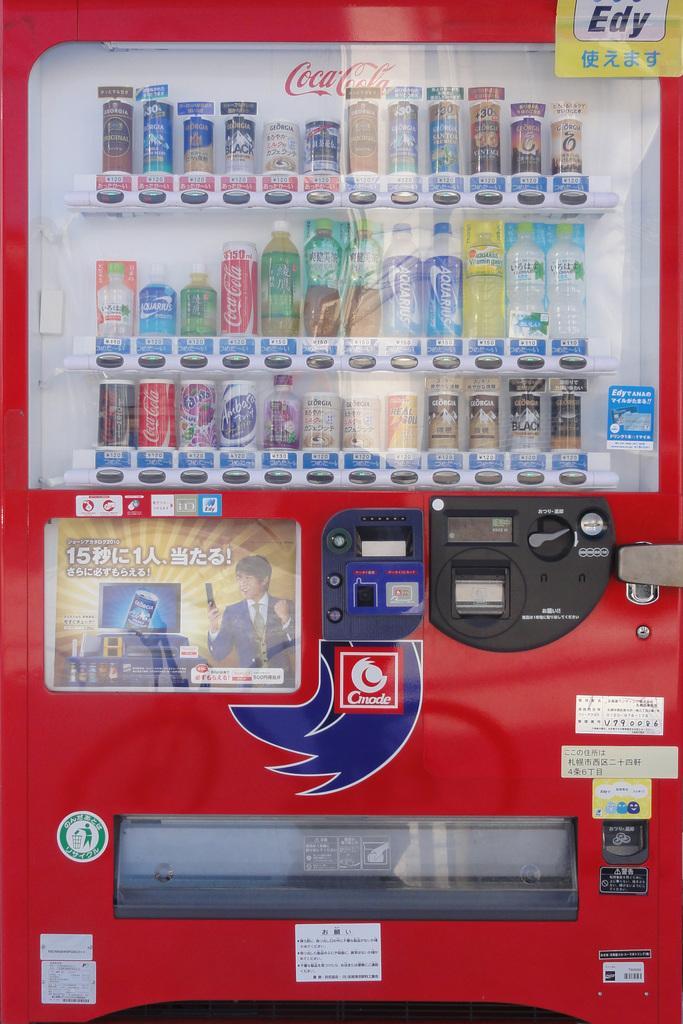Could you give a brief overview of what you see in this image? In this image we can see a vending machine with tins in it. 